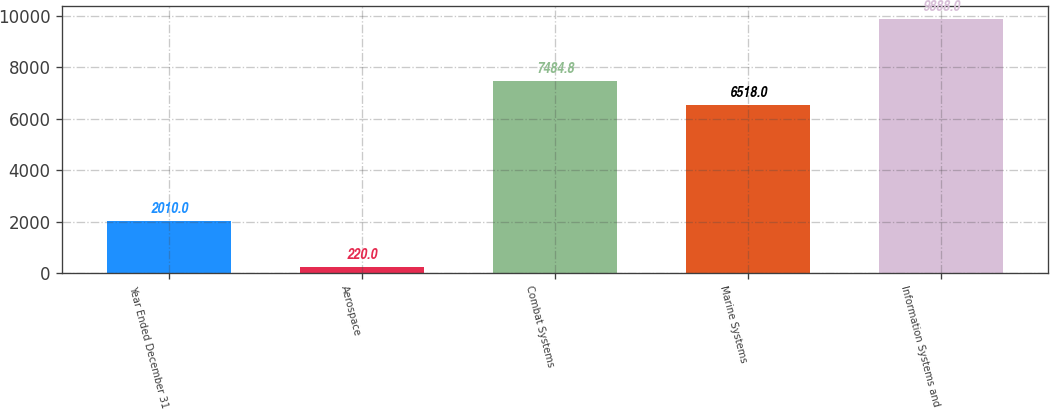Convert chart. <chart><loc_0><loc_0><loc_500><loc_500><bar_chart><fcel>Year Ended December 31<fcel>Aerospace<fcel>Combat Systems<fcel>Marine Systems<fcel>Information Systems and<nl><fcel>2010<fcel>220<fcel>7484.8<fcel>6518<fcel>9888<nl></chart> 